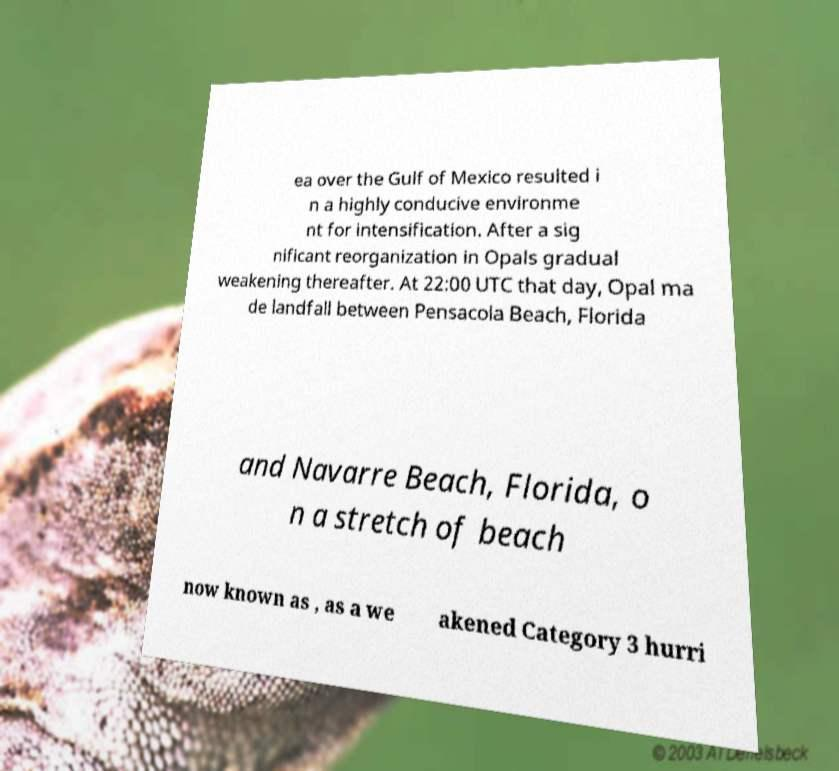Could you extract and type out the text from this image? ea over the Gulf of Mexico resulted i n a highly conducive environme nt for intensification. After a sig nificant reorganization in Opals gradual weakening thereafter. At 22:00 UTC that day, Opal ma de landfall between Pensacola Beach, Florida and Navarre Beach, Florida, o n a stretch of beach now known as , as a we akened Category 3 hurri 